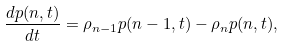Convert formula to latex. <formula><loc_0><loc_0><loc_500><loc_500>\frac { d p ( n , t ) } { d t } = \rho _ { n - 1 } p ( n - 1 , t ) - \rho _ { n } p ( n , t ) ,</formula> 